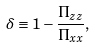<formula> <loc_0><loc_0><loc_500><loc_500>\delta \equiv 1 - \frac { \Pi _ { z z } } { \Pi _ { x x } } ,</formula> 